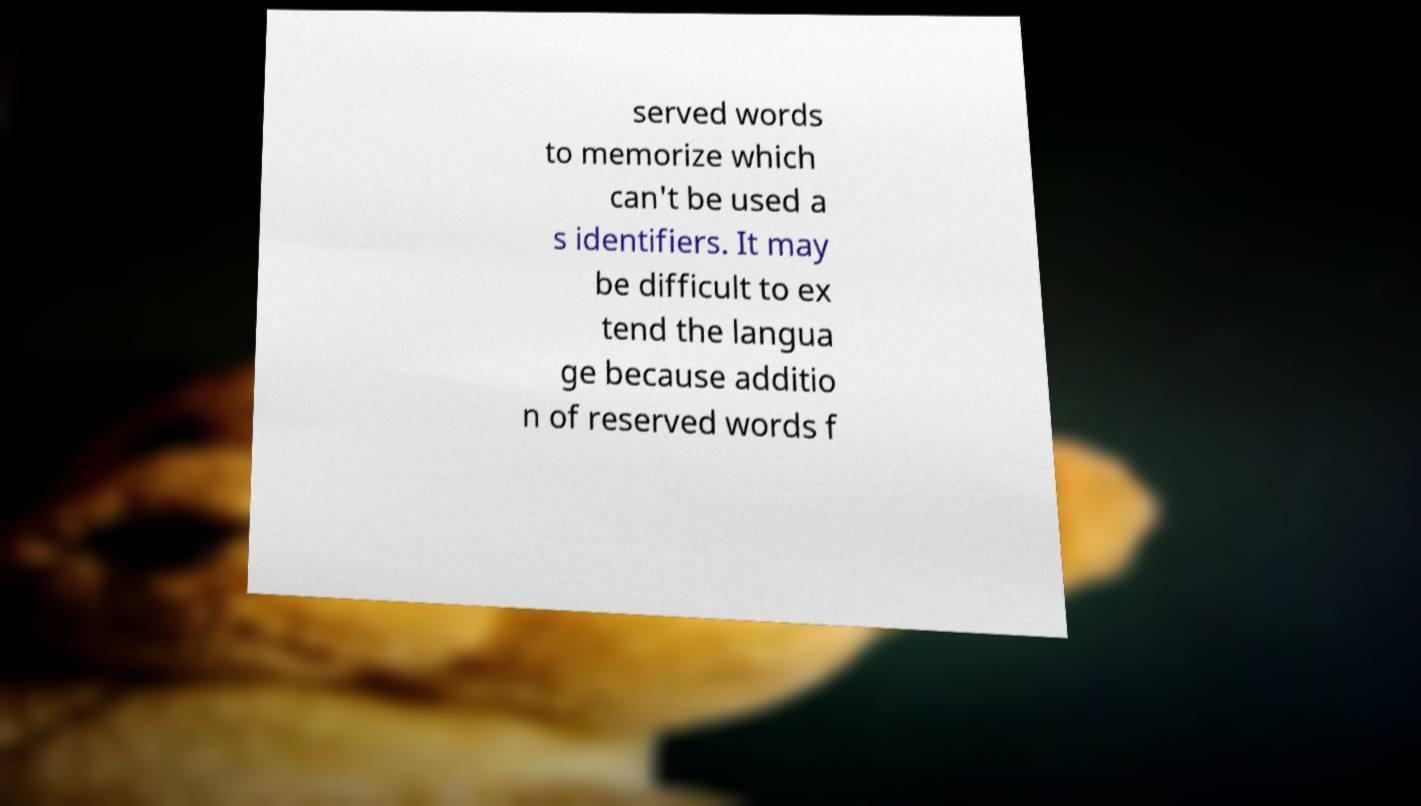Could you extract and type out the text from this image? served words to memorize which can't be used a s identifiers. It may be difficult to ex tend the langua ge because additio n of reserved words f 